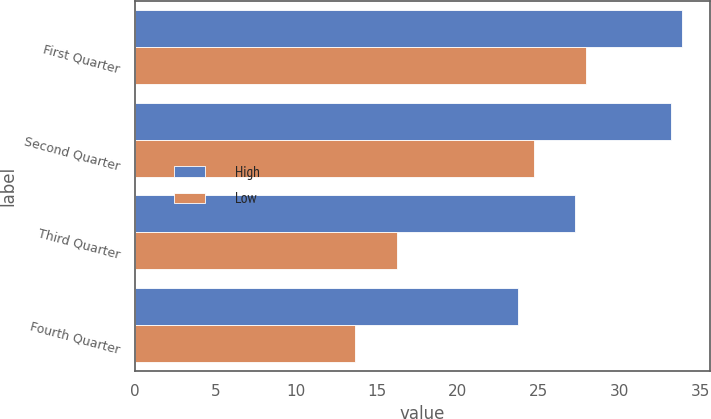<chart> <loc_0><loc_0><loc_500><loc_500><stacked_bar_chart><ecel><fcel>First Quarter<fcel>Second Quarter<fcel>Third Quarter<fcel>Fourth Quarter<nl><fcel>High<fcel>33.9<fcel>33.23<fcel>27.23<fcel>23.72<nl><fcel>Low<fcel>27.95<fcel>24.75<fcel>16.24<fcel>13.66<nl></chart> 